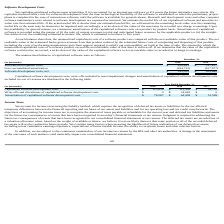According to Allscripts Healthcare Solutions's financial document, When is the purchased software capitalized? upon acquisition if it is accounted for as internal-use software or if it meets the future alternative use criteria. The document states: "We capitalize purchased software upon acquisition if it is accounted for as internal-use software or if it meets the future alternative use criteria. ..." Also, How is the amortization of capitalized software recorded? Based on the financial document, the answer is using the greater of (i) the ratio of current revenues to total and anticipated future revenues for the applicable product or (ii) the straightline method over the remaining estimated economic life, which is estimated to be three to five years.. Also, What is the Software development costs in 2019? According to the financial document, $428,641 (in thousands). The relevant text states: "Software development costs $ 428,641 $ 317,637..." Also, can you calculate: What is the change in the Software development costs from 2018 to 2019? Based on the calculation: 428,641 - 317,637, the result is 111004 (in thousands). This is based on the information: "Software development costs $ 428,641 $ 317,637 Software development costs $ 428,641 $ 317,637..." The key data points involved are: 317,637, 428,641. Also, can you calculate: What is the average accumulated amortization for 2018 and 2019? To answer this question, I need to perform calculations using the financial data. The calculation is: -(184,712 + 107,977) / 2, which equals -146344.5 (in thousands). This is based on the information: "Less: accumulated amortization (184,712) (107,977) Less: accumulated amortization (184,712) (107,977)..." The key data points involved are: 107,977, 184,712. Also, can you calculate: What is the percentage change in Software development costs, net from 2018 to 2019? To answer this question, I need to perform calculations using the financial data. The calculation is: 243,929 / 209,660 - 1, which equals 0.16 (percentage). This is based on the information: "Software development costs, net $ 243,929 $ 209,660 Software development costs, net $ 243,929 $ 209,660..." The key data points involved are: 209,660, 243,929. 